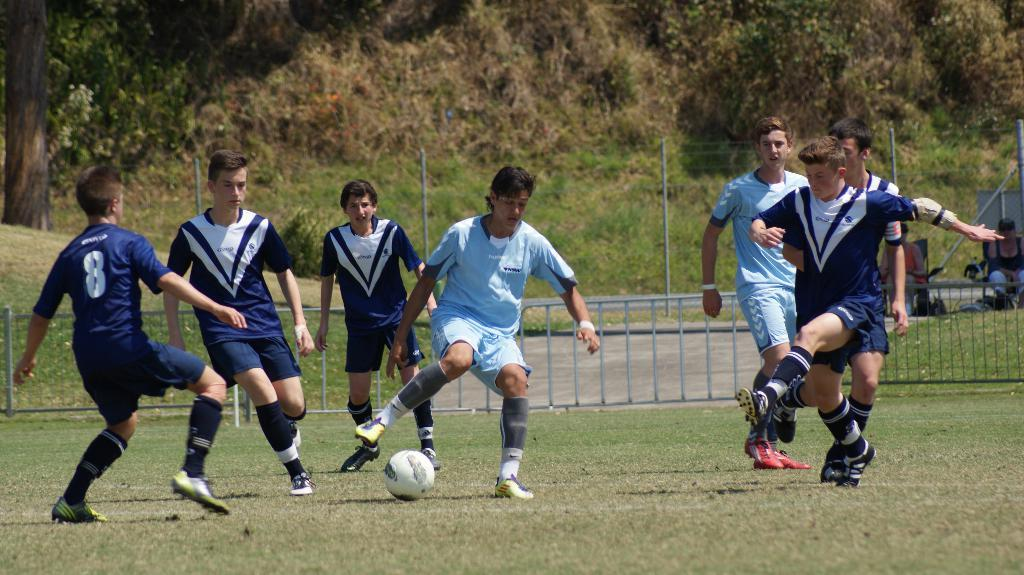What are the people in the image doing? The people in the image are playing football. What object is on the ground that is related to the game? There is a ball on the ground. What can be seen in the background of the image? There are trees visible in the image. Can you describe the seating arrangement of two persons in the image? Two persons are sitting on chairs. What type of knife is being used by the army in the image? There is no knife or army present in the image; it features a group of people playing football. What kind of lamp is illuminating the scene in the image? There is no lamp present in the image; the scene is illuminated by natural light. 